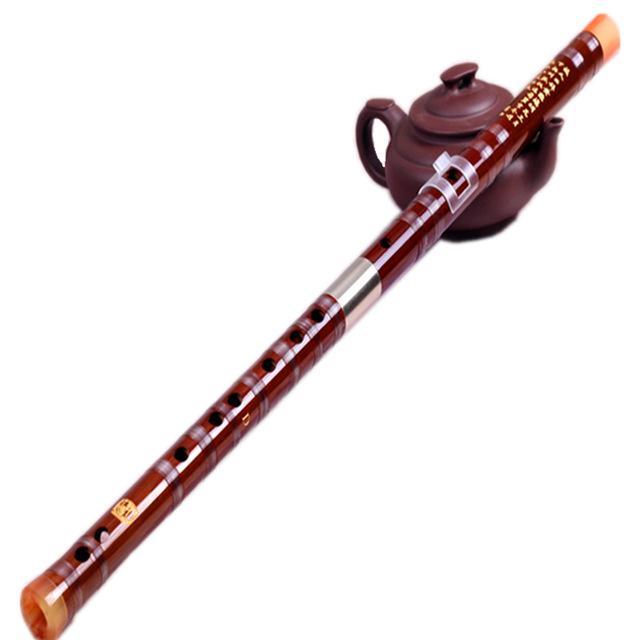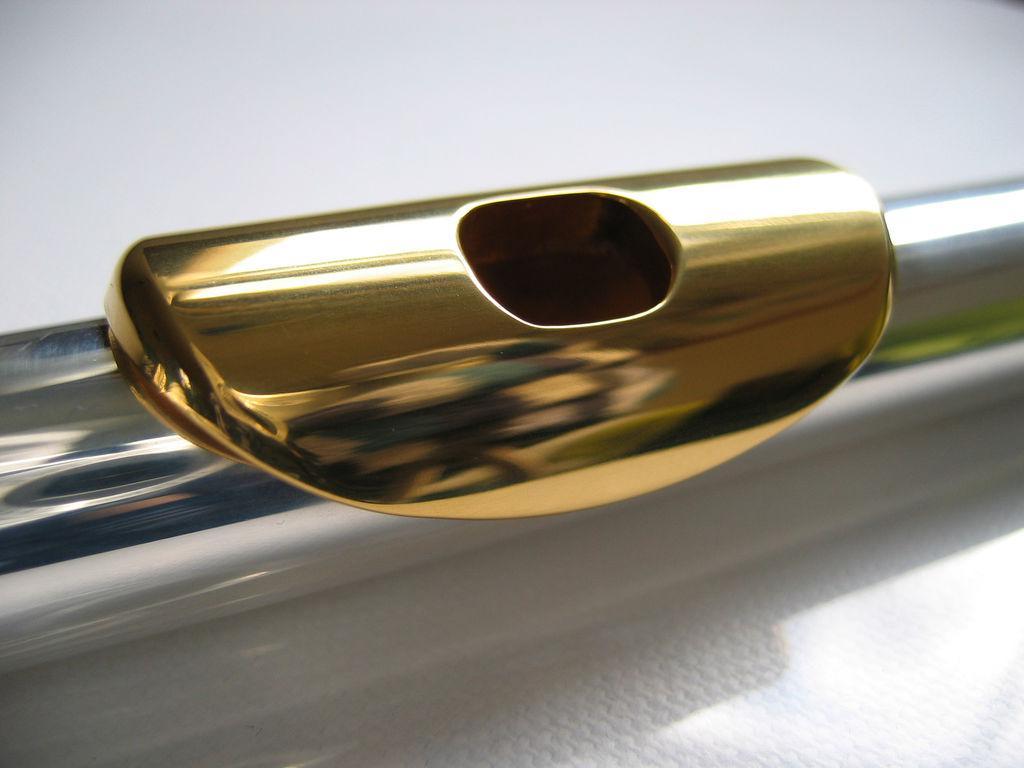The first image is the image on the left, the second image is the image on the right. Evaluate the accuracy of this statement regarding the images: "In the right image, the instrument mouthpiece is gold colored on a silver body.". Is it true? Answer yes or no. Yes. The first image is the image on the left, the second image is the image on the right. Analyze the images presented: Is the assertion "The right image shows a silver tube angled upward to the right, with a gold oblong shape with a hole in it near the middle of the tube." valid? Answer yes or no. Yes. 